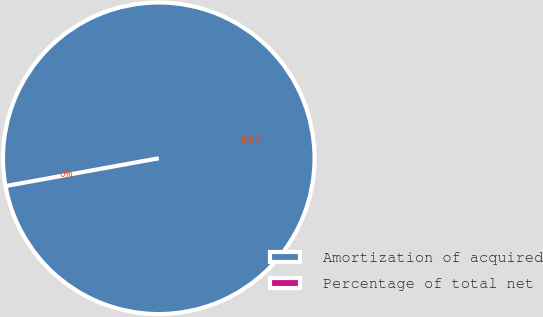Convert chart to OTSL. <chart><loc_0><loc_0><loc_500><loc_500><pie_chart><fcel>Amortization of acquired<fcel>Percentage of total net<nl><fcel>100.0%<fcel>0.0%<nl></chart> 